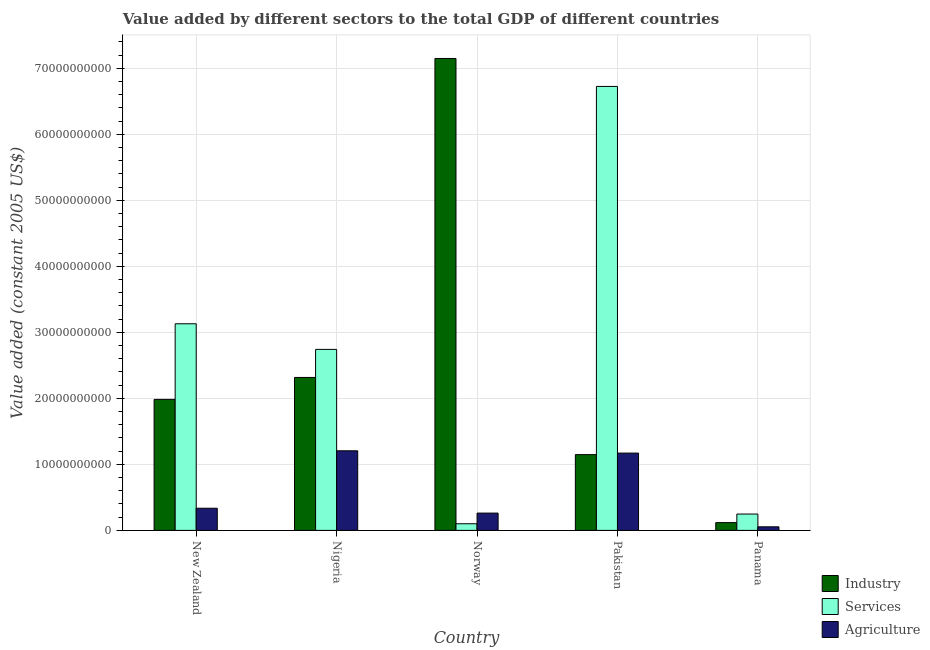How many different coloured bars are there?
Give a very brief answer. 3. How many groups of bars are there?
Provide a succinct answer. 5. Are the number of bars per tick equal to the number of legend labels?
Your answer should be very brief. Yes. How many bars are there on the 5th tick from the right?
Keep it short and to the point. 3. What is the value added by agricultural sector in Norway?
Ensure brevity in your answer.  2.62e+09. Across all countries, what is the maximum value added by agricultural sector?
Give a very brief answer. 1.21e+1. Across all countries, what is the minimum value added by agricultural sector?
Offer a terse response. 5.40e+08. In which country was the value added by agricultural sector minimum?
Offer a very short reply. Panama. What is the total value added by services in the graph?
Provide a short and direct response. 1.29e+11. What is the difference between the value added by agricultural sector in Pakistan and that in Panama?
Ensure brevity in your answer.  1.12e+1. What is the difference between the value added by industrial sector in Norway and the value added by agricultural sector in Pakistan?
Provide a succinct answer. 5.98e+1. What is the average value added by services per country?
Give a very brief answer. 2.59e+1. What is the difference between the value added by agricultural sector and value added by services in New Zealand?
Your answer should be compact. -2.79e+1. What is the ratio of the value added by agricultural sector in Pakistan to that in Panama?
Keep it short and to the point. 21.68. Is the difference between the value added by industrial sector in Norway and Panama greater than the difference between the value added by agricultural sector in Norway and Panama?
Your answer should be compact. Yes. What is the difference between the highest and the second highest value added by agricultural sector?
Provide a succinct answer. 3.47e+08. What is the difference between the highest and the lowest value added by agricultural sector?
Make the answer very short. 1.15e+1. In how many countries, is the value added by agricultural sector greater than the average value added by agricultural sector taken over all countries?
Give a very brief answer. 2. Is the sum of the value added by agricultural sector in New Zealand and Nigeria greater than the maximum value added by industrial sector across all countries?
Your response must be concise. No. What does the 2nd bar from the left in Pakistan represents?
Your response must be concise. Services. What does the 2nd bar from the right in Nigeria represents?
Your answer should be very brief. Services. Is it the case that in every country, the sum of the value added by industrial sector and value added by services is greater than the value added by agricultural sector?
Offer a terse response. Yes. How many countries are there in the graph?
Keep it short and to the point. 5. What is the difference between two consecutive major ticks on the Y-axis?
Your answer should be very brief. 1.00e+1. Are the values on the major ticks of Y-axis written in scientific E-notation?
Give a very brief answer. No. Does the graph contain any zero values?
Provide a short and direct response. No. Where does the legend appear in the graph?
Provide a short and direct response. Bottom right. How many legend labels are there?
Ensure brevity in your answer.  3. How are the legend labels stacked?
Give a very brief answer. Vertical. What is the title of the graph?
Ensure brevity in your answer.  Value added by different sectors to the total GDP of different countries. What is the label or title of the Y-axis?
Keep it short and to the point. Value added (constant 2005 US$). What is the Value added (constant 2005 US$) in Industry in New Zealand?
Your answer should be very brief. 1.98e+1. What is the Value added (constant 2005 US$) in Services in New Zealand?
Provide a short and direct response. 3.13e+1. What is the Value added (constant 2005 US$) in Agriculture in New Zealand?
Make the answer very short. 3.36e+09. What is the Value added (constant 2005 US$) in Industry in Nigeria?
Your answer should be very brief. 2.32e+1. What is the Value added (constant 2005 US$) in Services in Nigeria?
Ensure brevity in your answer.  2.74e+1. What is the Value added (constant 2005 US$) of Agriculture in Nigeria?
Make the answer very short. 1.21e+1. What is the Value added (constant 2005 US$) of Industry in Norway?
Keep it short and to the point. 7.15e+1. What is the Value added (constant 2005 US$) of Services in Norway?
Ensure brevity in your answer.  1.01e+09. What is the Value added (constant 2005 US$) in Agriculture in Norway?
Keep it short and to the point. 2.62e+09. What is the Value added (constant 2005 US$) in Industry in Pakistan?
Provide a short and direct response. 1.15e+1. What is the Value added (constant 2005 US$) in Services in Pakistan?
Offer a terse response. 6.73e+1. What is the Value added (constant 2005 US$) in Agriculture in Pakistan?
Give a very brief answer. 1.17e+1. What is the Value added (constant 2005 US$) of Industry in Panama?
Provide a short and direct response. 1.18e+09. What is the Value added (constant 2005 US$) of Services in Panama?
Provide a short and direct response. 2.48e+09. What is the Value added (constant 2005 US$) in Agriculture in Panama?
Offer a terse response. 5.40e+08. Across all countries, what is the maximum Value added (constant 2005 US$) of Industry?
Ensure brevity in your answer.  7.15e+1. Across all countries, what is the maximum Value added (constant 2005 US$) in Services?
Your answer should be very brief. 6.73e+1. Across all countries, what is the maximum Value added (constant 2005 US$) of Agriculture?
Provide a succinct answer. 1.21e+1. Across all countries, what is the minimum Value added (constant 2005 US$) in Industry?
Your answer should be very brief. 1.18e+09. Across all countries, what is the minimum Value added (constant 2005 US$) of Services?
Provide a short and direct response. 1.01e+09. Across all countries, what is the minimum Value added (constant 2005 US$) of Agriculture?
Offer a terse response. 5.40e+08. What is the total Value added (constant 2005 US$) in Industry in the graph?
Provide a short and direct response. 1.27e+11. What is the total Value added (constant 2005 US$) of Services in the graph?
Your answer should be compact. 1.29e+11. What is the total Value added (constant 2005 US$) in Agriculture in the graph?
Your answer should be compact. 3.03e+1. What is the difference between the Value added (constant 2005 US$) in Industry in New Zealand and that in Nigeria?
Your answer should be compact. -3.32e+09. What is the difference between the Value added (constant 2005 US$) of Services in New Zealand and that in Nigeria?
Offer a terse response. 3.88e+09. What is the difference between the Value added (constant 2005 US$) of Agriculture in New Zealand and that in Nigeria?
Provide a short and direct response. -8.70e+09. What is the difference between the Value added (constant 2005 US$) in Industry in New Zealand and that in Norway?
Give a very brief answer. -5.16e+1. What is the difference between the Value added (constant 2005 US$) in Services in New Zealand and that in Norway?
Make the answer very short. 3.03e+1. What is the difference between the Value added (constant 2005 US$) of Agriculture in New Zealand and that in Norway?
Give a very brief answer. 7.36e+08. What is the difference between the Value added (constant 2005 US$) of Industry in New Zealand and that in Pakistan?
Offer a very short reply. 8.37e+09. What is the difference between the Value added (constant 2005 US$) of Services in New Zealand and that in Pakistan?
Your response must be concise. -3.60e+1. What is the difference between the Value added (constant 2005 US$) of Agriculture in New Zealand and that in Pakistan?
Provide a short and direct response. -8.35e+09. What is the difference between the Value added (constant 2005 US$) in Industry in New Zealand and that in Panama?
Make the answer very short. 1.87e+1. What is the difference between the Value added (constant 2005 US$) in Services in New Zealand and that in Panama?
Give a very brief answer. 2.88e+1. What is the difference between the Value added (constant 2005 US$) in Agriculture in New Zealand and that in Panama?
Provide a short and direct response. 2.82e+09. What is the difference between the Value added (constant 2005 US$) of Industry in Nigeria and that in Norway?
Your answer should be very brief. -4.83e+1. What is the difference between the Value added (constant 2005 US$) in Services in Nigeria and that in Norway?
Your response must be concise. 2.64e+1. What is the difference between the Value added (constant 2005 US$) of Agriculture in Nigeria and that in Norway?
Keep it short and to the point. 9.44e+09. What is the difference between the Value added (constant 2005 US$) of Industry in Nigeria and that in Pakistan?
Your answer should be very brief. 1.17e+1. What is the difference between the Value added (constant 2005 US$) in Services in Nigeria and that in Pakistan?
Provide a succinct answer. -3.98e+1. What is the difference between the Value added (constant 2005 US$) of Agriculture in Nigeria and that in Pakistan?
Offer a terse response. 3.47e+08. What is the difference between the Value added (constant 2005 US$) in Industry in Nigeria and that in Panama?
Make the answer very short. 2.20e+1. What is the difference between the Value added (constant 2005 US$) of Services in Nigeria and that in Panama?
Provide a succinct answer. 2.49e+1. What is the difference between the Value added (constant 2005 US$) in Agriculture in Nigeria and that in Panama?
Your answer should be very brief. 1.15e+1. What is the difference between the Value added (constant 2005 US$) of Industry in Norway and that in Pakistan?
Make the answer very short. 6.00e+1. What is the difference between the Value added (constant 2005 US$) in Services in Norway and that in Pakistan?
Provide a succinct answer. -6.62e+1. What is the difference between the Value added (constant 2005 US$) of Agriculture in Norway and that in Pakistan?
Make the answer very short. -9.09e+09. What is the difference between the Value added (constant 2005 US$) of Industry in Norway and that in Panama?
Provide a short and direct response. 7.03e+1. What is the difference between the Value added (constant 2005 US$) of Services in Norway and that in Panama?
Provide a short and direct response. -1.47e+09. What is the difference between the Value added (constant 2005 US$) in Agriculture in Norway and that in Panama?
Your answer should be compact. 2.08e+09. What is the difference between the Value added (constant 2005 US$) in Industry in Pakistan and that in Panama?
Offer a terse response. 1.03e+1. What is the difference between the Value added (constant 2005 US$) of Services in Pakistan and that in Panama?
Your answer should be very brief. 6.48e+1. What is the difference between the Value added (constant 2005 US$) of Agriculture in Pakistan and that in Panama?
Make the answer very short. 1.12e+1. What is the difference between the Value added (constant 2005 US$) of Industry in New Zealand and the Value added (constant 2005 US$) of Services in Nigeria?
Provide a succinct answer. -7.57e+09. What is the difference between the Value added (constant 2005 US$) of Industry in New Zealand and the Value added (constant 2005 US$) of Agriculture in Nigeria?
Your answer should be compact. 7.79e+09. What is the difference between the Value added (constant 2005 US$) of Services in New Zealand and the Value added (constant 2005 US$) of Agriculture in Nigeria?
Offer a very short reply. 1.92e+1. What is the difference between the Value added (constant 2005 US$) in Industry in New Zealand and the Value added (constant 2005 US$) in Services in Norway?
Make the answer very short. 1.88e+1. What is the difference between the Value added (constant 2005 US$) in Industry in New Zealand and the Value added (constant 2005 US$) in Agriculture in Norway?
Provide a short and direct response. 1.72e+1. What is the difference between the Value added (constant 2005 US$) of Services in New Zealand and the Value added (constant 2005 US$) of Agriculture in Norway?
Ensure brevity in your answer.  2.87e+1. What is the difference between the Value added (constant 2005 US$) in Industry in New Zealand and the Value added (constant 2005 US$) in Services in Pakistan?
Offer a very short reply. -4.74e+1. What is the difference between the Value added (constant 2005 US$) of Industry in New Zealand and the Value added (constant 2005 US$) of Agriculture in Pakistan?
Offer a very short reply. 8.13e+09. What is the difference between the Value added (constant 2005 US$) in Services in New Zealand and the Value added (constant 2005 US$) in Agriculture in Pakistan?
Your response must be concise. 1.96e+1. What is the difference between the Value added (constant 2005 US$) in Industry in New Zealand and the Value added (constant 2005 US$) in Services in Panama?
Provide a succinct answer. 1.74e+1. What is the difference between the Value added (constant 2005 US$) in Industry in New Zealand and the Value added (constant 2005 US$) in Agriculture in Panama?
Make the answer very short. 1.93e+1. What is the difference between the Value added (constant 2005 US$) of Services in New Zealand and the Value added (constant 2005 US$) of Agriculture in Panama?
Ensure brevity in your answer.  3.08e+1. What is the difference between the Value added (constant 2005 US$) of Industry in Nigeria and the Value added (constant 2005 US$) of Services in Norway?
Give a very brief answer. 2.22e+1. What is the difference between the Value added (constant 2005 US$) of Industry in Nigeria and the Value added (constant 2005 US$) of Agriculture in Norway?
Your answer should be compact. 2.05e+1. What is the difference between the Value added (constant 2005 US$) of Services in Nigeria and the Value added (constant 2005 US$) of Agriculture in Norway?
Your answer should be compact. 2.48e+1. What is the difference between the Value added (constant 2005 US$) in Industry in Nigeria and the Value added (constant 2005 US$) in Services in Pakistan?
Provide a short and direct response. -4.41e+1. What is the difference between the Value added (constant 2005 US$) of Industry in Nigeria and the Value added (constant 2005 US$) of Agriculture in Pakistan?
Offer a very short reply. 1.15e+1. What is the difference between the Value added (constant 2005 US$) of Services in Nigeria and the Value added (constant 2005 US$) of Agriculture in Pakistan?
Offer a very short reply. 1.57e+1. What is the difference between the Value added (constant 2005 US$) of Industry in Nigeria and the Value added (constant 2005 US$) of Services in Panama?
Your answer should be very brief. 2.07e+1. What is the difference between the Value added (constant 2005 US$) of Industry in Nigeria and the Value added (constant 2005 US$) of Agriculture in Panama?
Your answer should be compact. 2.26e+1. What is the difference between the Value added (constant 2005 US$) in Services in Nigeria and the Value added (constant 2005 US$) in Agriculture in Panama?
Offer a very short reply. 2.69e+1. What is the difference between the Value added (constant 2005 US$) of Industry in Norway and the Value added (constant 2005 US$) of Services in Pakistan?
Your answer should be very brief. 4.23e+09. What is the difference between the Value added (constant 2005 US$) in Industry in Norway and the Value added (constant 2005 US$) in Agriculture in Pakistan?
Your answer should be very brief. 5.98e+1. What is the difference between the Value added (constant 2005 US$) of Services in Norway and the Value added (constant 2005 US$) of Agriculture in Pakistan?
Your response must be concise. -1.07e+1. What is the difference between the Value added (constant 2005 US$) of Industry in Norway and the Value added (constant 2005 US$) of Services in Panama?
Make the answer very short. 6.90e+1. What is the difference between the Value added (constant 2005 US$) in Industry in Norway and the Value added (constant 2005 US$) in Agriculture in Panama?
Your answer should be compact. 7.09e+1. What is the difference between the Value added (constant 2005 US$) of Services in Norway and the Value added (constant 2005 US$) of Agriculture in Panama?
Your response must be concise. 4.65e+08. What is the difference between the Value added (constant 2005 US$) in Industry in Pakistan and the Value added (constant 2005 US$) in Services in Panama?
Provide a succinct answer. 9.00e+09. What is the difference between the Value added (constant 2005 US$) in Industry in Pakistan and the Value added (constant 2005 US$) in Agriculture in Panama?
Your response must be concise. 1.09e+1. What is the difference between the Value added (constant 2005 US$) of Services in Pakistan and the Value added (constant 2005 US$) of Agriculture in Panama?
Keep it short and to the point. 6.67e+1. What is the average Value added (constant 2005 US$) of Industry per country?
Offer a very short reply. 2.54e+1. What is the average Value added (constant 2005 US$) in Services per country?
Your answer should be compact. 2.59e+1. What is the average Value added (constant 2005 US$) in Agriculture per country?
Keep it short and to the point. 6.06e+09. What is the difference between the Value added (constant 2005 US$) of Industry and Value added (constant 2005 US$) of Services in New Zealand?
Your response must be concise. -1.15e+1. What is the difference between the Value added (constant 2005 US$) of Industry and Value added (constant 2005 US$) of Agriculture in New Zealand?
Offer a very short reply. 1.65e+1. What is the difference between the Value added (constant 2005 US$) in Services and Value added (constant 2005 US$) in Agriculture in New Zealand?
Ensure brevity in your answer.  2.79e+1. What is the difference between the Value added (constant 2005 US$) in Industry and Value added (constant 2005 US$) in Services in Nigeria?
Give a very brief answer. -4.25e+09. What is the difference between the Value added (constant 2005 US$) of Industry and Value added (constant 2005 US$) of Agriculture in Nigeria?
Provide a succinct answer. 1.11e+1. What is the difference between the Value added (constant 2005 US$) of Services and Value added (constant 2005 US$) of Agriculture in Nigeria?
Make the answer very short. 1.54e+1. What is the difference between the Value added (constant 2005 US$) of Industry and Value added (constant 2005 US$) of Services in Norway?
Keep it short and to the point. 7.05e+1. What is the difference between the Value added (constant 2005 US$) in Industry and Value added (constant 2005 US$) in Agriculture in Norway?
Ensure brevity in your answer.  6.89e+1. What is the difference between the Value added (constant 2005 US$) of Services and Value added (constant 2005 US$) of Agriculture in Norway?
Make the answer very short. -1.62e+09. What is the difference between the Value added (constant 2005 US$) in Industry and Value added (constant 2005 US$) in Services in Pakistan?
Give a very brief answer. -5.58e+1. What is the difference between the Value added (constant 2005 US$) of Industry and Value added (constant 2005 US$) of Agriculture in Pakistan?
Keep it short and to the point. -2.32e+08. What is the difference between the Value added (constant 2005 US$) in Services and Value added (constant 2005 US$) in Agriculture in Pakistan?
Provide a short and direct response. 5.55e+1. What is the difference between the Value added (constant 2005 US$) in Industry and Value added (constant 2005 US$) in Services in Panama?
Provide a short and direct response. -1.30e+09. What is the difference between the Value added (constant 2005 US$) of Industry and Value added (constant 2005 US$) of Agriculture in Panama?
Offer a very short reply. 6.36e+08. What is the difference between the Value added (constant 2005 US$) in Services and Value added (constant 2005 US$) in Agriculture in Panama?
Provide a succinct answer. 1.94e+09. What is the ratio of the Value added (constant 2005 US$) in Industry in New Zealand to that in Nigeria?
Provide a succinct answer. 0.86. What is the ratio of the Value added (constant 2005 US$) in Services in New Zealand to that in Nigeria?
Your response must be concise. 1.14. What is the ratio of the Value added (constant 2005 US$) of Agriculture in New Zealand to that in Nigeria?
Ensure brevity in your answer.  0.28. What is the ratio of the Value added (constant 2005 US$) in Industry in New Zealand to that in Norway?
Make the answer very short. 0.28. What is the ratio of the Value added (constant 2005 US$) in Services in New Zealand to that in Norway?
Your answer should be compact. 31.14. What is the ratio of the Value added (constant 2005 US$) of Agriculture in New Zealand to that in Norway?
Offer a very short reply. 1.28. What is the ratio of the Value added (constant 2005 US$) in Industry in New Zealand to that in Pakistan?
Make the answer very short. 1.73. What is the ratio of the Value added (constant 2005 US$) of Services in New Zealand to that in Pakistan?
Offer a very short reply. 0.47. What is the ratio of the Value added (constant 2005 US$) of Agriculture in New Zealand to that in Pakistan?
Offer a very short reply. 0.29. What is the ratio of the Value added (constant 2005 US$) in Industry in New Zealand to that in Panama?
Give a very brief answer. 16.87. What is the ratio of the Value added (constant 2005 US$) of Services in New Zealand to that in Panama?
Make the answer very short. 12.63. What is the ratio of the Value added (constant 2005 US$) of Agriculture in New Zealand to that in Panama?
Keep it short and to the point. 6.22. What is the ratio of the Value added (constant 2005 US$) of Industry in Nigeria to that in Norway?
Give a very brief answer. 0.32. What is the ratio of the Value added (constant 2005 US$) of Services in Nigeria to that in Norway?
Provide a short and direct response. 27.28. What is the ratio of the Value added (constant 2005 US$) of Agriculture in Nigeria to that in Norway?
Offer a terse response. 4.6. What is the ratio of the Value added (constant 2005 US$) in Industry in Nigeria to that in Pakistan?
Your answer should be very brief. 2.02. What is the ratio of the Value added (constant 2005 US$) in Services in Nigeria to that in Pakistan?
Give a very brief answer. 0.41. What is the ratio of the Value added (constant 2005 US$) in Agriculture in Nigeria to that in Pakistan?
Your answer should be very brief. 1.03. What is the ratio of the Value added (constant 2005 US$) in Industry in Nigeria to that in Panama?
Your answer should be very brief. 19.69. What is the ratio of the Value added (constant 2005 US$) of Services in Nigeria to that in Panama?
Provide a short and direct response. 11.07. What is the ratio of the Value added (constant 2005 US$) in Agriculture in Nigeria to that in Panama?
Ensure brevity in your answer.  22.33. What is the ratio of the Value added (constant 2005 US$) of Industry in Norway to that in Pakistan?
Your answer should be very brief. 6.23. What is the ratio of the Value added (constant 2005 US$) in Services in Norway to that in Pakistan?
Ensure brevity in your answer.  0.01. What is the ratio of the Value added (constant 2005 US$) in Agriculture in Norway to that in Pakistan?
Provide a succinct answer. 0.22. What is the ratio of the Value added (constant 2005 US$) in Industry in Norway to that in Panama?
Your answer should be very brief. 60.76. What is the ratio of the Value added (constant 2005 US$) in Services in Norway to that in Panama?
Keep it short and to the point. 0.41. What is the ratio of the Value added (constant 2005 US$) of Agriculture in Norway to that in Panama?
Offer a very short reply. 4.85. What is the ratio of the Value added (constant 2005 US$) in Industry in Pakistan to that in Panama?
Give a very brief answer. 9.76. What is the ratio of the Value added (constant 2005 US$) of Services in Pakistan to that in Panama?
Offer a terse response. 27.15. What is the ratio of the Value added (constant 2005 US$) of Agriculture in Pakistan to that in Panama?
Your answer should be very brief. 21.68. What is the difference between the highest and the second highest Value added (constant 2005 US$) of Industry?
Ensure brevity in your answer.  4.83e+1. What is the difference between the highest and the second highest Value added (constant 2005 US$) in Services?
Keep it short and to the point. 3.60e+1. What is the difference between the highest and the second highest Value added (constant 2005 US$) of Agriculture?
Your answer should be very brief. 3.47e+08. What is the difference between the highest and the lowest Value added (constant 2005 US$) in Industry?
Your answer should be very brief. 7.03e+1. What is the difference between the highest and the lowest Value added (constant 2005 US$) in Services?
Provide a succinct answer. 6.62e+1. What is the difference between the highest and the lowest Value added (constant 2005 US$) in Agriculture?
Make the answer very short. 1.15e+1. 